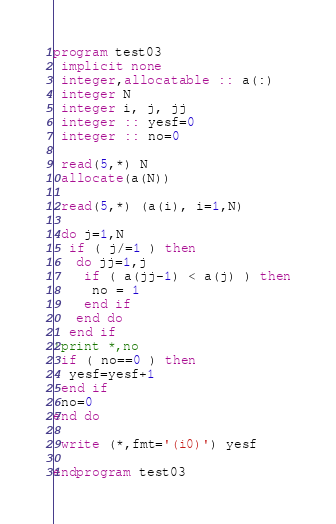Convert code to text. <code><loc_0><loc_0><loc_500><loc_500><_FORTRAN_>program test03
 implicit none
 integer,allocatable :: a(:)
 integer N
 integer i, j, jj
 integer :: yesf=0
 integer :: no=0

 read(5,*) N
 allocate(a(N))

 read(5,*) (a(i), i=1,N)

 do j=1,N
  if ( j/=1 ) then
   do jj=1,j
    if ( a(jj-1) < a(j) ) then
     no = 1
    end if
   end do
  end if
!print *,no
 if ( no==0 ) then
  yesf=yesf+1
 end if
 no=0
end do

 write (*,fmt='(i0)') yesf

endprogram test03
</code> 